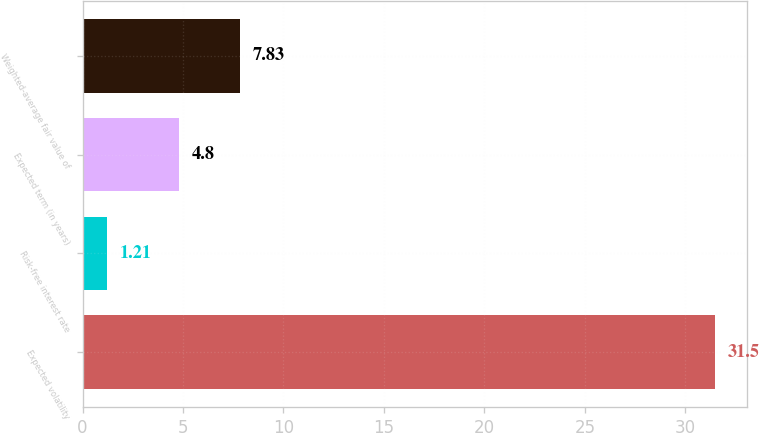Convert chart to OTSL. <chart><loc_0><loc_0><loc_500><loc_500><bar_chart><fcel>Expected volatility<fcel>Risk-free interest rate<fcel>Expected term (in years)<fcel>Weighted-average fair value of<nl><fcel>31.5<fcel>1.21<fcel>4.8<fcel>7.83<nl></chart> 